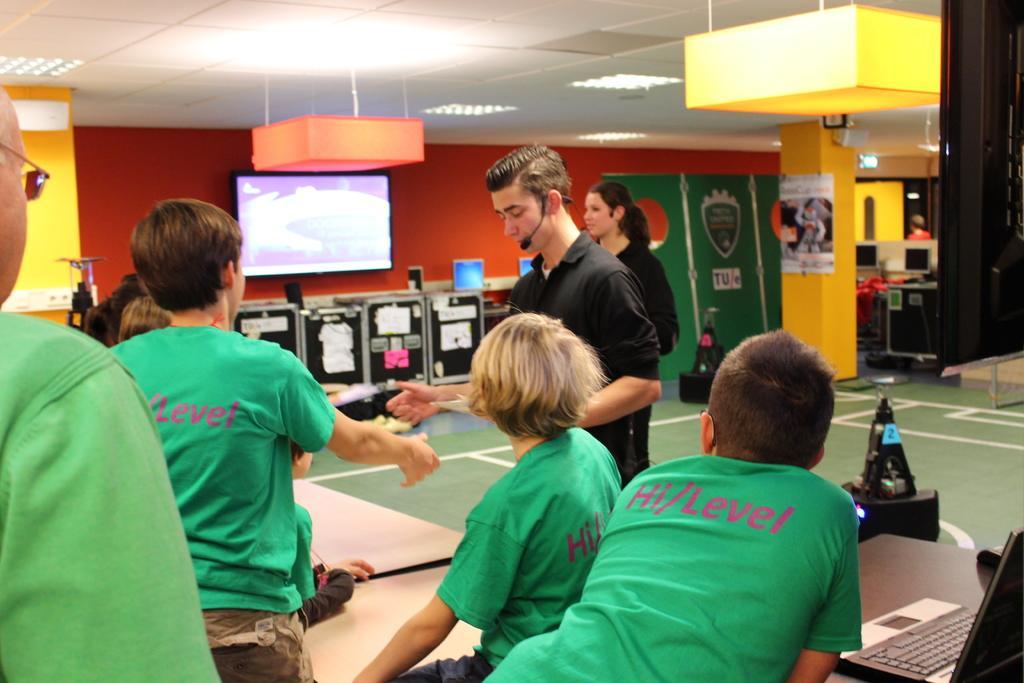How would you summarize this image in a sentence or two? In this image we can see few persons are standing and a person among them is sitting on a table. In the background there is a TV on the wall, papers attached to the boxes, board on the pillar, objects, lights on the ceiling and on the right side there is a laptop on a table. 